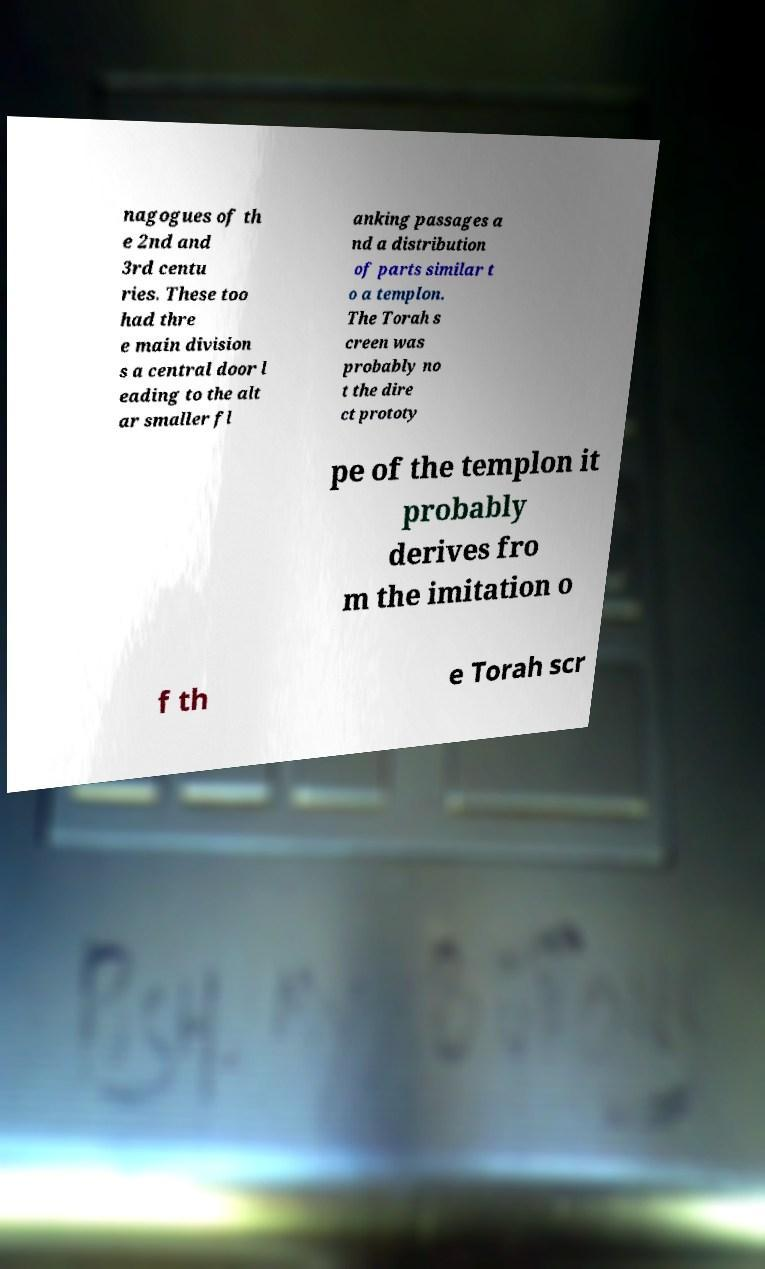Please read and relay the text visible in this image. What does it say? nagogues of th e 2nd and 3rd centu ries. These too had thre e main division s a central door l eading to the alt ar smaller fl anking passages a nd a distribution of parts similar t o a templon. The Torah s creen was probably no t the dire ct prototy pe of the templon it probably derives fro m the imitation o f th e Torah scr 